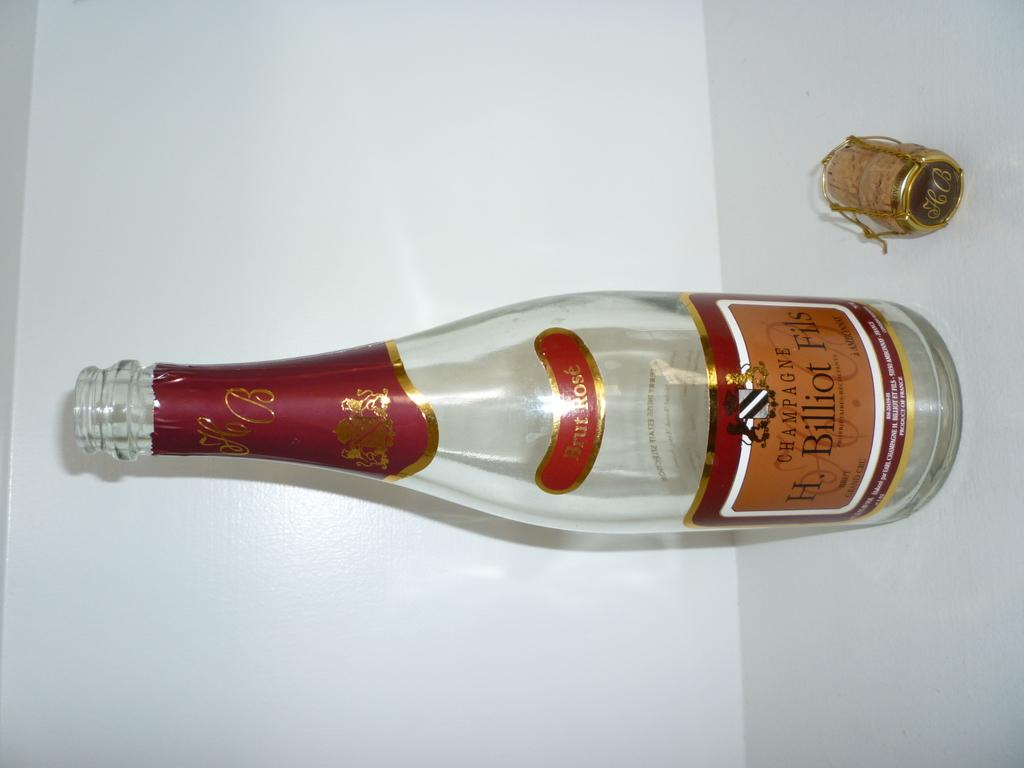<image>
Provide a brief description of the given image. A bottle of H. Billiot Fils Champagne and its cork. 